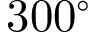Convert formula to latex. <formula><loc_0><loc_0><loc_500><loc_500>3 0 0 ^ { \circ }</formula> 